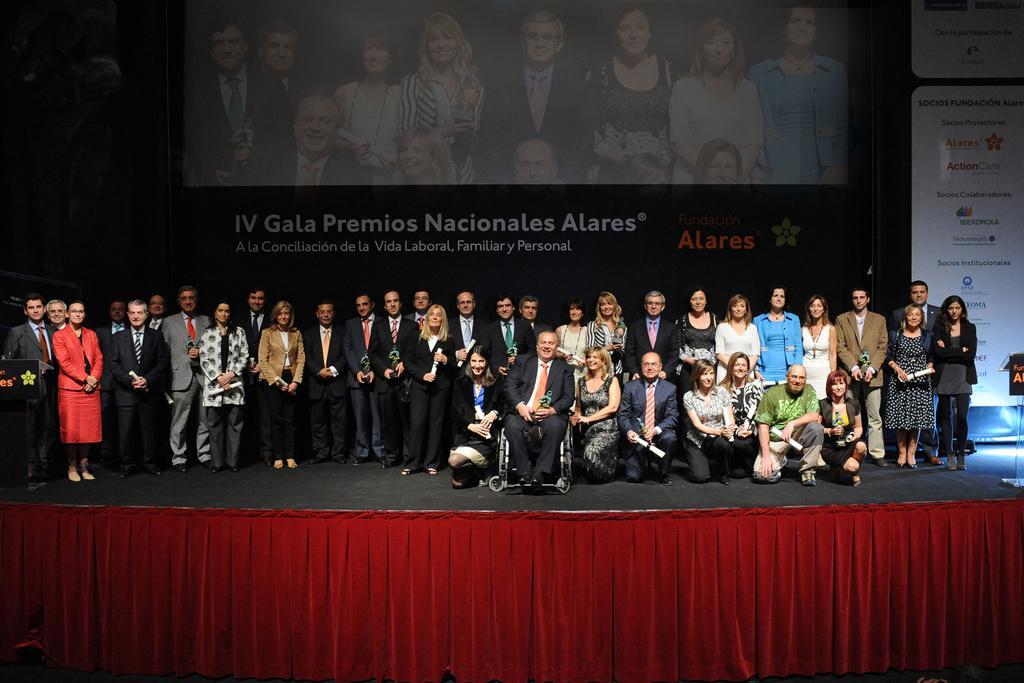Could you give a brief overview of what you see in this image? In the center of the image there are few people standing on the stage and there are few people sitting. In front of them there are curtains. Behind them there is a screen. There are banners. On the left side of the image there is a dais. On top of it there is a mike. 